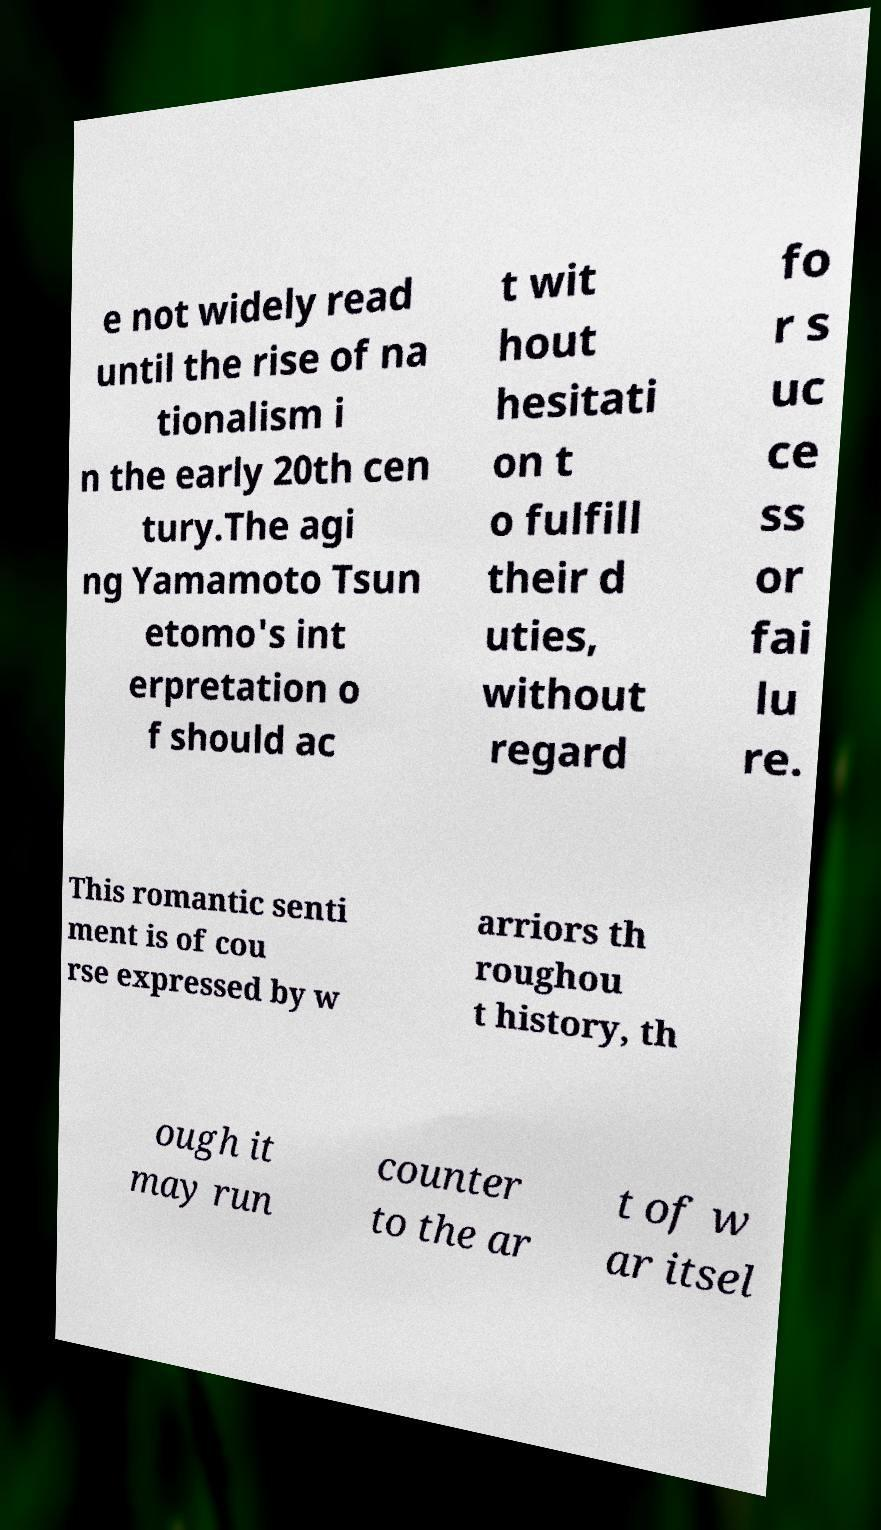Could you extract and type out the text from this image? e not widely read until the rise of na tionalism i n the early 20th cen tury.The agi ng Yamamoto Tsun etomo's int erpretation o f should ac t wit hout hesitati on t o fulfill their d uties, without regard fo r s uc ce ss or fai lu re. This romantic senti ment is of cou rse expressed by w arriors th roughou t history, th ough it may run counter to the ar t of w ar itsel 